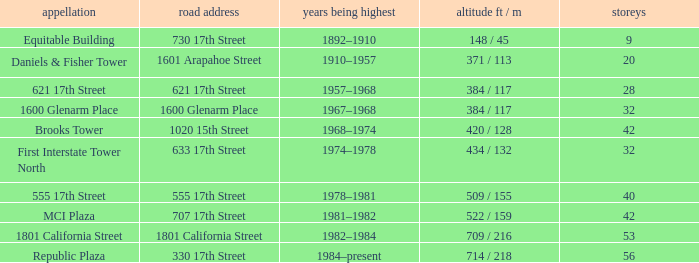What is the height of the building named 555 17th street? 509 / 155. 